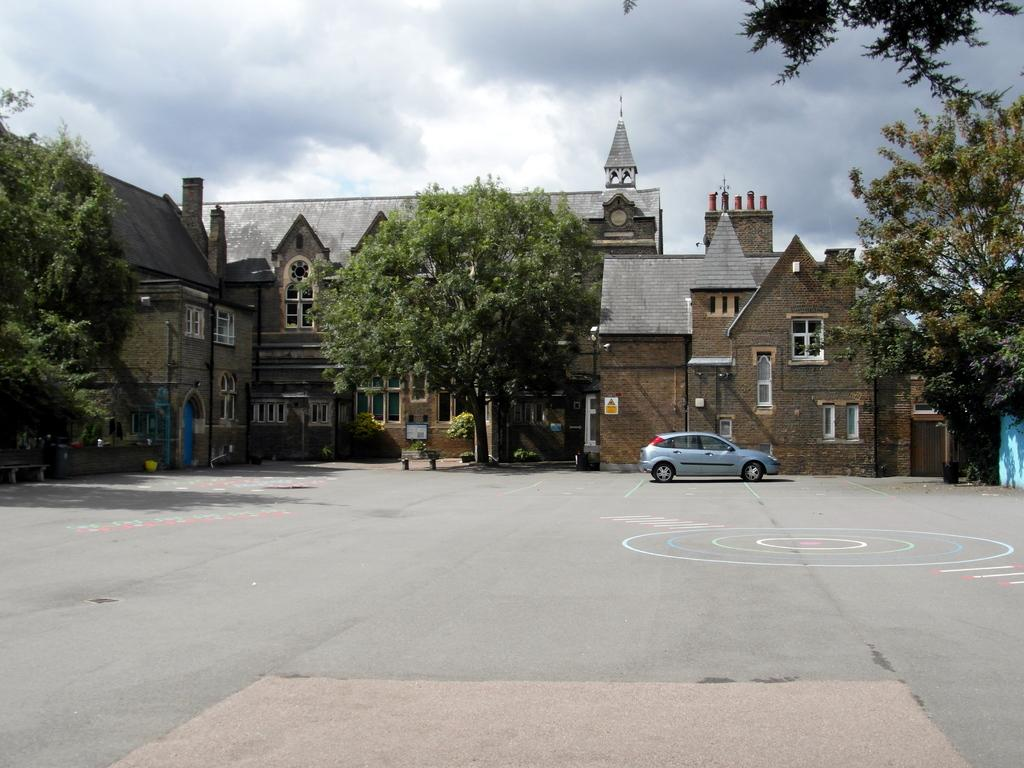What is the main feature of the image? There is a road in the image. What can be seen in the distance behind the road? There are buildings, trees, a car, and a bench in the background of the image. What is visible in the sky in the image? The sky is visible in the background of the image. What type of chain can be seen hanging from the trees in the image? There is no chain hanging from the trees in the image. What kind of pear is being used as a decoration on the car in the image? There is no pear present in the image, and the car is not shown to have any decorations. 